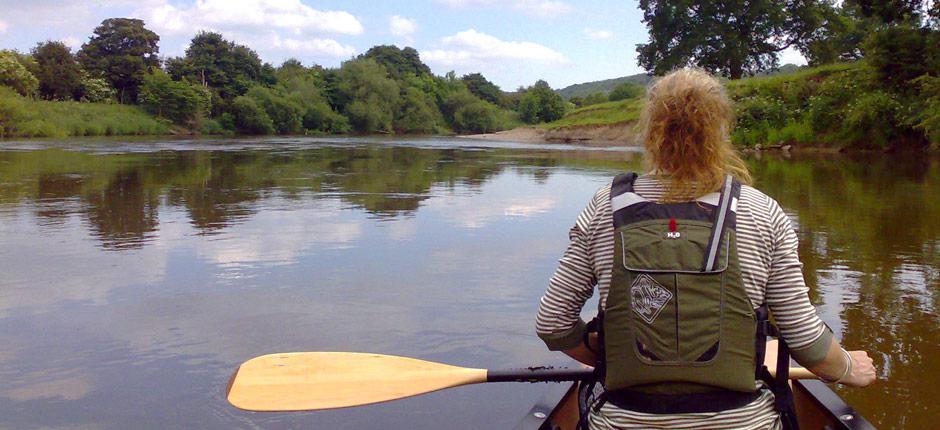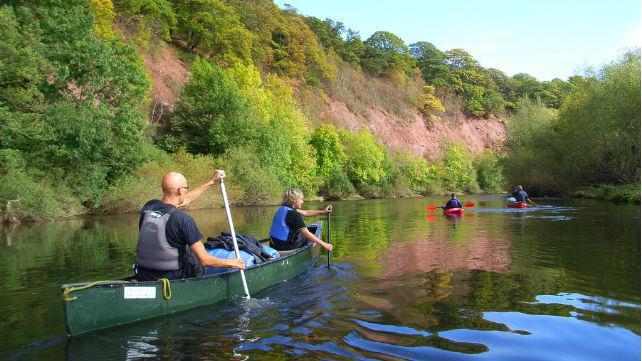The first image is the image on the left, the second image is the image on the right. Evaluate the accuracy of this statement regarding the images: "In at least one image there are a total three small boat.". Is it true? Answer yes or no. Yes. The first image is the image on the left, the second image is the image on the right. Given the left and right images, does the statement "The right image shows red oars." hold true? Answer yes or no. No. 